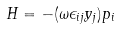Convert formula to latex. <formula><loc_0><loc_0><loc_500><loc_500>H = - ( \omega \epsilon _ { i j } y _ { j } ) p _ { i }</formula> 